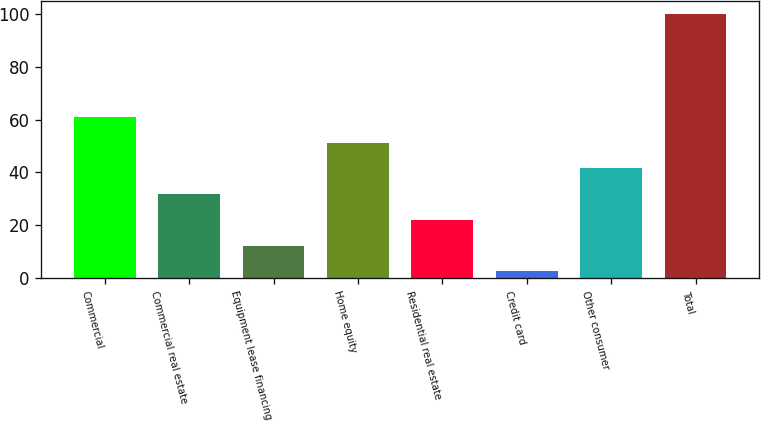Convert chart. <chart><loc_0><loc_0><loc_500><loc_500><bar_chart><fcel>Commercial<fcel>Commercial real estate<fcel>Equipment lease financing<fcel>Home equity<fcel>Residential real estate<fcel>Credit card<fcel>Other consumer<fcel>Total<nl><fcel>61<fcel>31.75<fcel>12.25<fcel>51.25<fcel>22<fcel>2.5<fcel>41.5<fcel>100<nl></chart> 